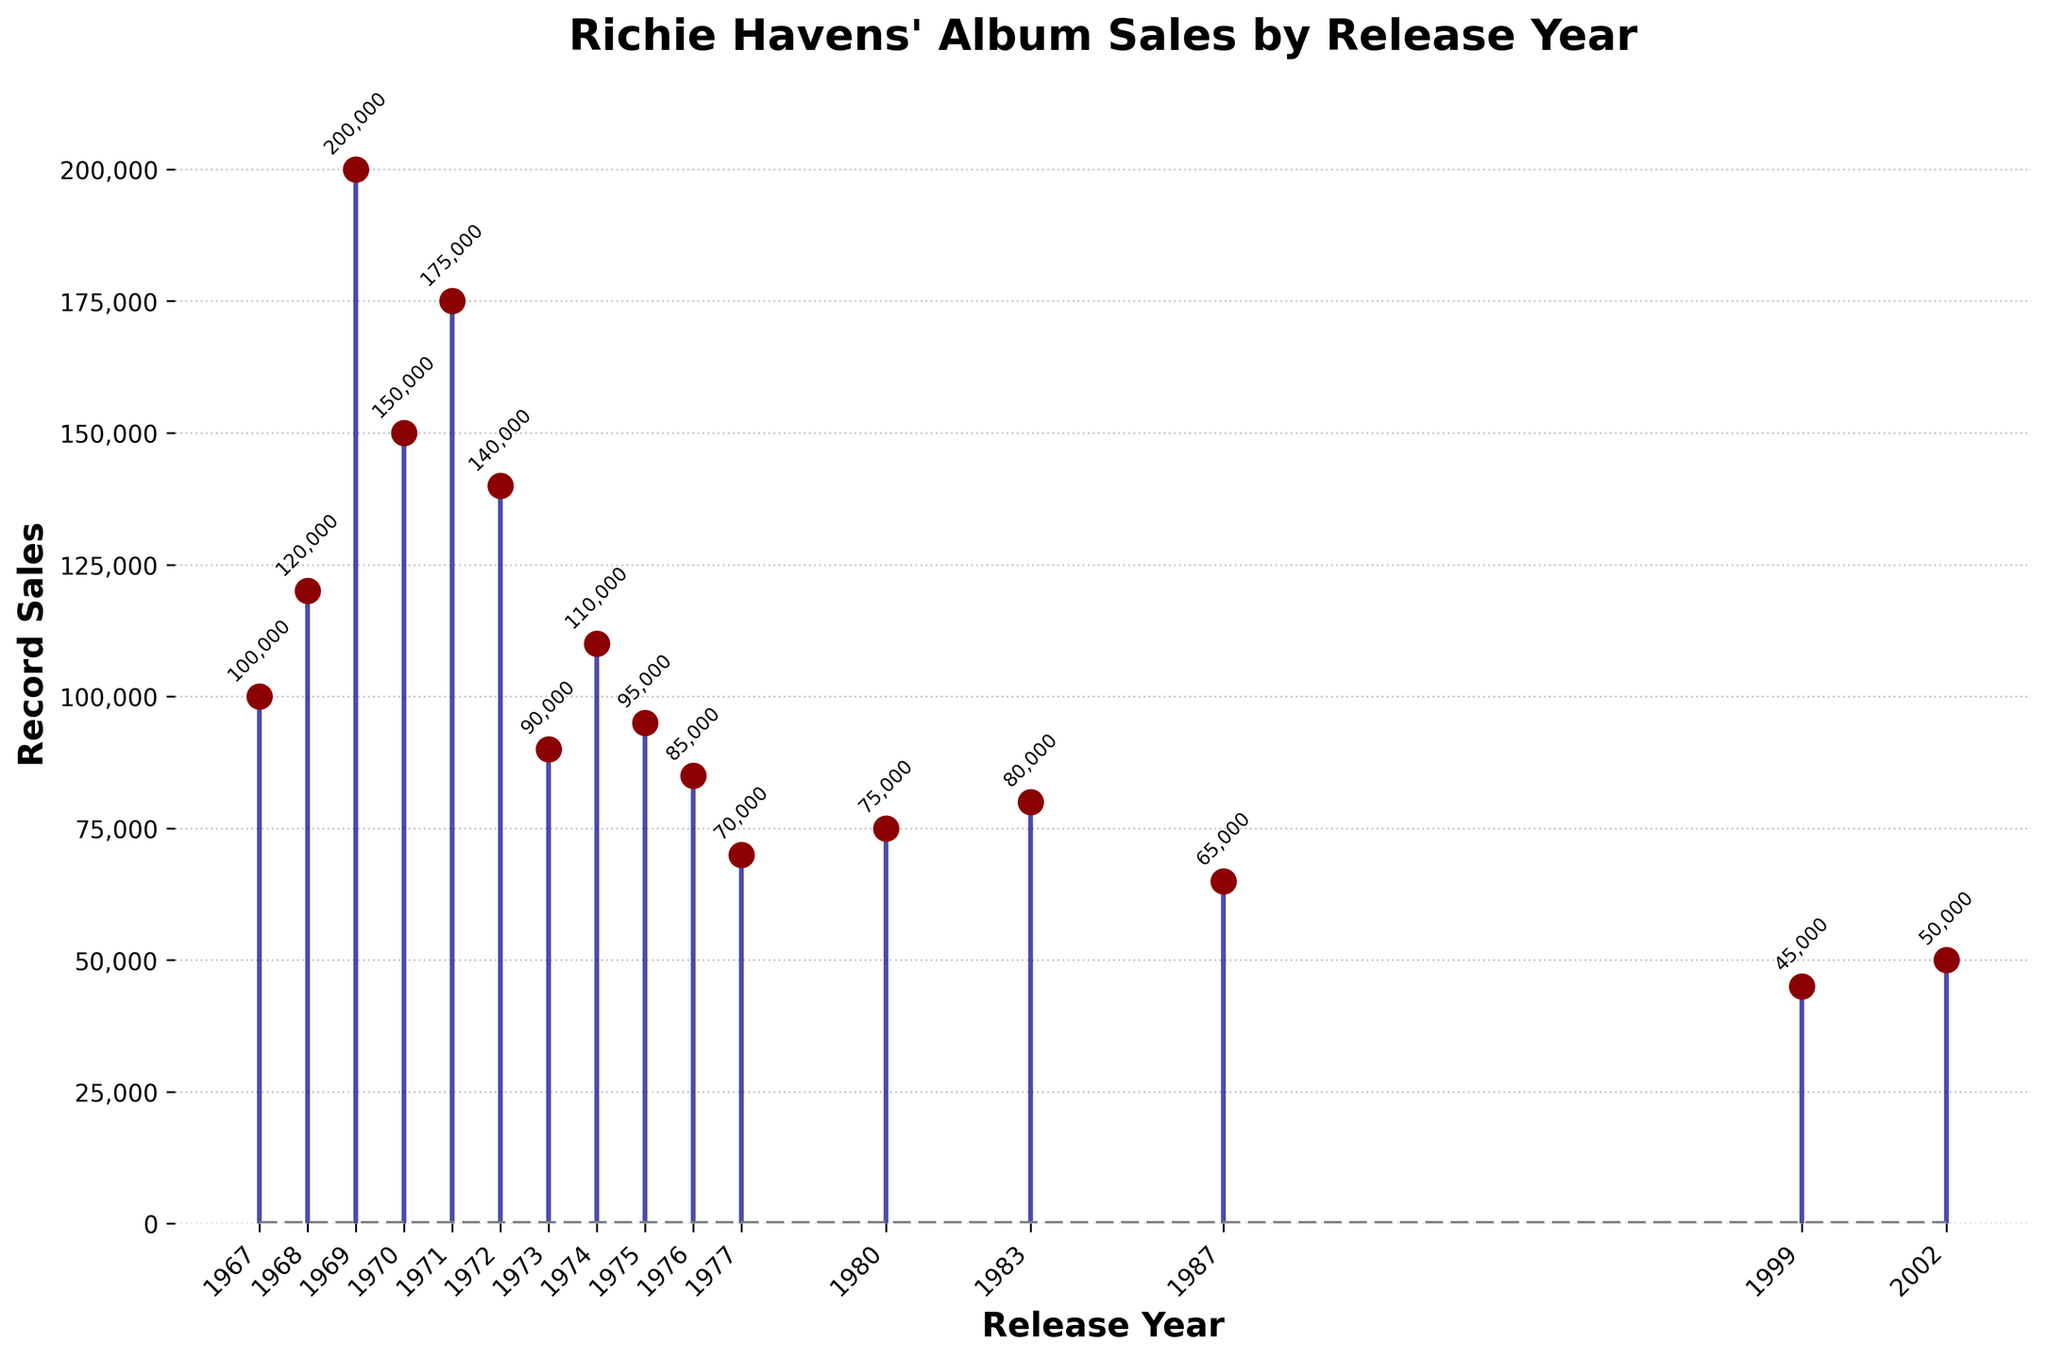What is the title of the figure? The title of the figure is mentioned at the top of the chart. It reads, "Richie Havens' Album Sales by Release Year."
Answer: Richie Havens' Album Sales by Release Year Which album had the highest record sales? The data points in the figure indicate different albums and their corresponding sales in a given year. The album 'Richard P. Havens 1983' in the year 1969 has the highest recorded sales of 200,000.
Answer: Richard P. Havens 1983 What are the highest and lowest record sales in the dataset? Examining the stems in the figure, the highest stem is at 200,000 (for 'Richard P. Havens 1983') and the lowest is at 45,000 (for 'Time').
Answer: 200,000 and 45,000 How many albums had record sales greater than 100,000? To answer this, count the stems that surpass the 100,000 mark. These include 'Mixed Bag', 'Something Else Again', 'Richard P. Havens 1983', 'Stonehenge', 'Alarm Clock', 'Live at the Cellar Door', and 'Mixed Bag II'. There are 7 such albums.
Answer: 7 Which album released after 1980 had the highest record sales? The stems for albums released after 1980 are compared, and 'Common Ground' released in 1983 with 80,000 sales has the highest record sales among those years.
Answer: Common Ground What's the difference in sales between 'Mixed Bag' and 'Mixed Bag II'? Locate 'Mixed Bag' in 1967 with 100,000 sales and 'Mixed Bag II' in 1974 with 110,000 sales. The difference is found by subtraction: 110,000 - 100,000 = 10,000.
Answer: 10,000 Which year between 1967 and 1977 had the lowest record sales? By looking at the stems from 1967 to 1977, 'Mirrage' in 1977 with 70,000 sales stands as the lowest.
Answer: 1977 What is the average record sales of albums released in the 1970s? Sum the sales of albums released in the 1970s (150,000 + 175,000 + 140,000 + 90,000 + 110,000 + 95,000 + 85,000 + 70,000 = 915,000) and divide by the number of albums (8). The average is 915,000 / 8 = 114,375.
Answer: 114,375 How does the sales trend change from 1967 to 1987? The trend starts high in the late 1960s, peaks in 1969, and generally declines into the 1980s, with some fluctuations. Sales drop from 200,000 in 1969 to 65,000 in 1987.
Answer: Declining with fluctuations How many albums sold between 60,000 and 90,000 copies? Identify and count the stems that fall in the range 60,000 to 90,000: 'Portfolio' with 90,000, 'The End of the Beginning' with 95,000, 'Endless Journey' with 85,000, 'Mirrage' with 70,000, and 'Sings Beatles & Dylan' with 65,000. That makes 5 albums.
Answer: 5 